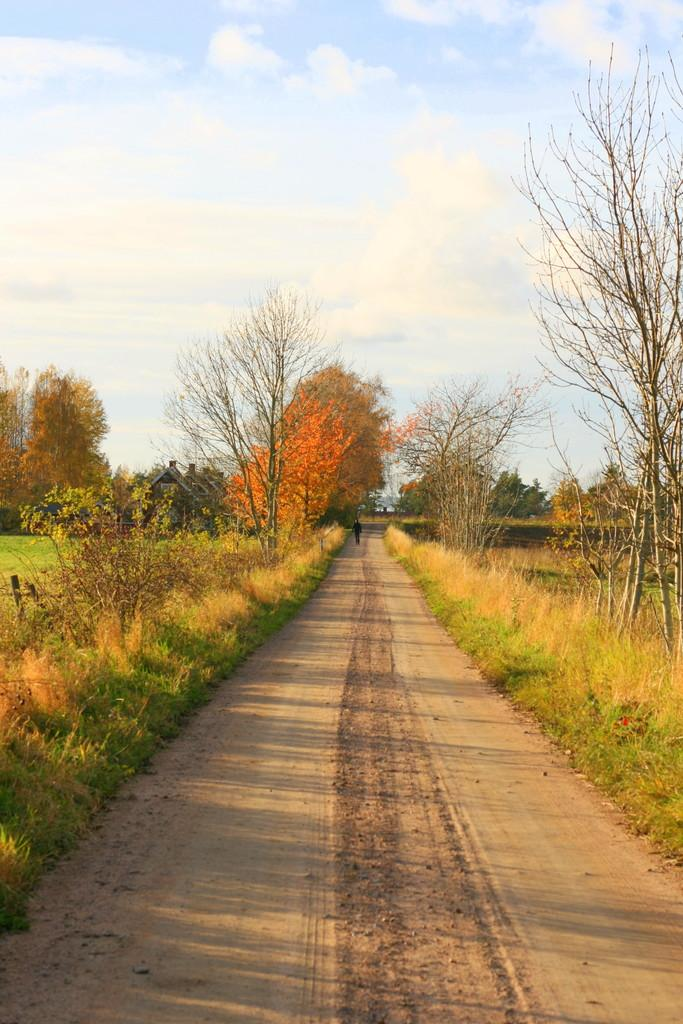What type of surface can be seen in the image? There is a path in the image. What type of vegetation is present in the image? There is grass, plants, and trees in the image. Is there any human presence in the image? Yes, there is a person standing in the image. Are there any structures visible in the image? Yes, there are houses in the image. What is visible in the background of the image? The sky is visible in the background of the image. How many apples are being held by the cattle in the image? There are no cattle or apples present in the image. What fact can be determined about the person's age from the image? The image does not provide any information about the person's age, so it cannot be determined from the image. 